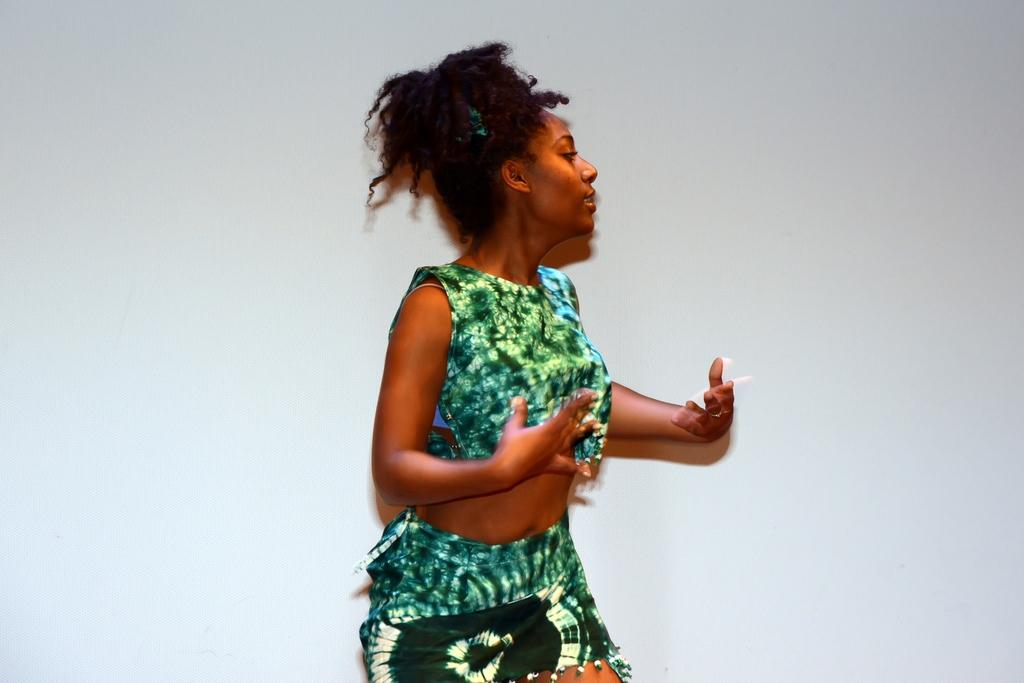Who is the main subject in the image? There is a woman in the image. What is the woman wearing? The woman is wearing a dress. How would you describe the woman's appearance? The woman is stunning. What can be seen in the background of the image? There is a wall in the background of the image. What type of coal can be seen near the woman in the image? There is no coal present in the image; it only features a woman and a wall in the background. 